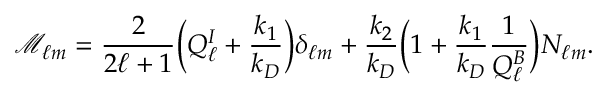Convert formula to latex. <formula><loc_0><loc_0><loc_500><loc_500>\mathcal { M } _ { \ell m } = \frac { 2 } { 2 \ell + 1 } \left ( Q _ { \ell } ^ { I } + \frac { k _ { 1 } } { k _ { D } } \right ) \delta _ { \ell m } + \frac { k _ { 2 } } { k _ { D } } \left ( 1 + \frac { k _ { 1 } } { k _ { D } } \frac { 1 } { Q _ { \ell } ^ { B } } \right ) N _ { \ell m } .</formula> 